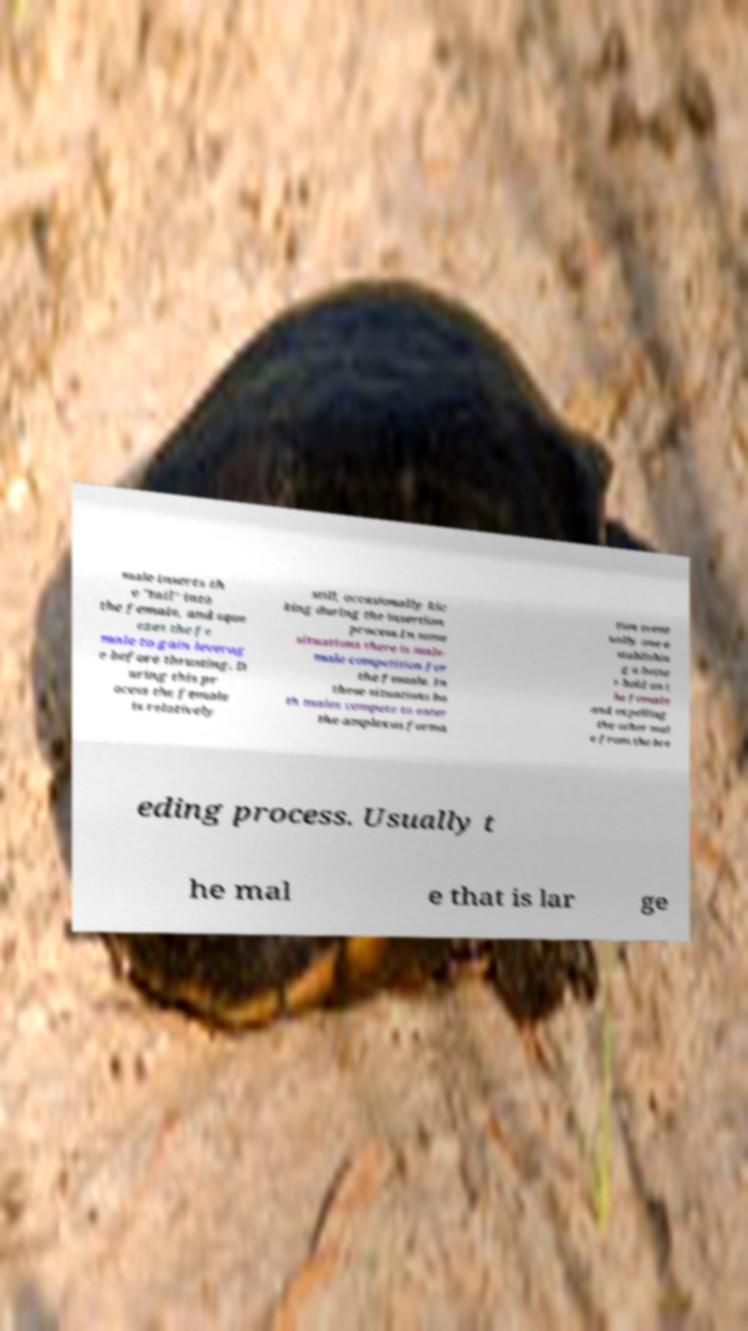Can you accurately transcribe the text from the provided image for me? male inserts th e "tail" into the female, and sque ezes the fe male to gain leverag e before thrusting. D uring this pr ocess the female is relatively still, occasionally kic king during the insertion process.In some situations there is male- male competition for the female. In these situations bo th males compete to enter the amplexus forma tion event ually one e stablishin g a bette r hold on t he female and expelling the other mal e from the bre eding process. Usually t he mal e that is lar ge 